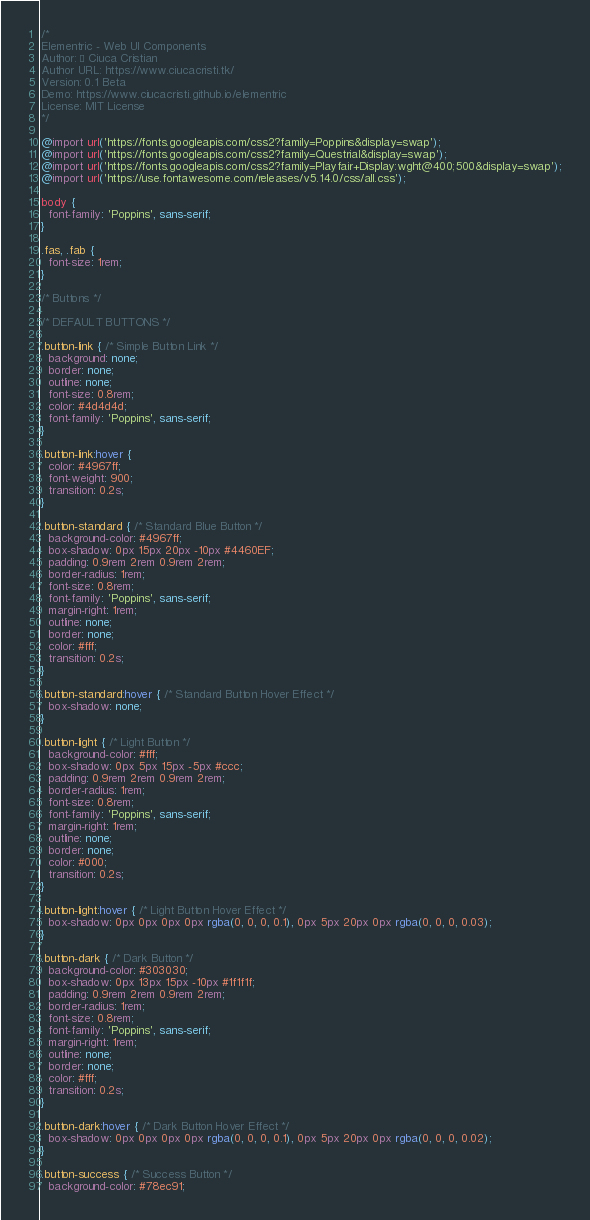Convert code to text. <code><loc_0><loc_0><loc_500><loc_500><_CSS_>/*
Elementric - Web UI Components
Author: © Ciuca Cristian
Author URL: https://www.ciucacristi.tk/
Version: 0.1 Beta
Demo: https://www.ciucacristi.github.io/elementric
License: MIT License
*/

@import url('https://fonts.googleapis.com/css2?family=Poppins&display=swap');
@import url('https://fonts.googleapis.com/css2?family=Questrial&display=swap');
@import url('https://fonts.googleapis.com/css2?family=Playfair+Display:wght@400;500&display=swap');
@import url('https://use.fontawesome.com/releases/v5.14.0/css/all.css');

body {
  font-family: 'Poppins', sans-serif;
}

.fas, .fab {
  font-size: 1rem;
}

/* Buttons */

/* DEFAULT BUTTONS */

.button-link { /* Simple Button Link */
  background: none;
  border: none;
  outline: none;
  font-size: 0.8rem;
  color: #4d4d4d;
  font-family: 'Poppins', sans-serif;
}

.button-link:hover {
  color: #4967ff;
  font-weight: 900;
  transition: 0.2s;
}

.button-standard { /* Standard Blue Button */
  background-color: #4967ff;
  box-shadow: 0px 15px 20px -10px #4460EF;
  padding: 0.9rem 2rem 0.9rem 2rem;
  border-radius: 1rem;
  font-size: 0.8rem;
  font-family: 'Poppins', sans-serif;
  margin-right: 1rem;
  outline: none;
  border: none;
  color: #fff;
  transition: 0.2s;
}

.button-standard:hover { /* Standard Button Hover Effect */
  box-shadow: none;
}

.button-light { /* Light Button */
  background-color: #fff;
  box-shadow: 0px 5px 15px -5px #ccc;
  padding: 0.9rem 2rem 0.9rem 2rem;
  border-radius: 1rem;
  font-size: 0.8rem;
  font-family: 'Poppins', sans-serif;
  margin-right: 1rem;
  outline: none;
  border: none;
  color: #000;
  transition: 0.2s;
}

.button-light:hover { /* Light Button Hover Effect */
  box-shadow: 0px 0px 0px 0px rgba(0, 0, 0, 0.1), 0px 5px 20px 0px rgba(0, 0, 0, 0.03);
}

.button-dark { /* Dark Button */
  background-color: #303030;
  box-shadow: 0px 13px 15px -10px #1f1f1f;
  padding: 0.9rem 2rem 0.9rem 2rem;
  border-radius: 1rem;
  font-size: 0.8rem;
  font-family: 'Poppins', sans-serif;
  margin-right: 1rem;
  outline: none;
  border: none;
  color: #fff;
  transition: 0.2s;
}

.button-dark:hover { /* Dark Button Hover Effect */
  box-shadow: 0px 0px 0px 0px rgba(0, 0, 0, 0.1), 0px 5px 20px 0px rgba(0, 0, 0, 0.02);
}

.button-success { /* Success Button */
  background-color: #78ec91;</code> 